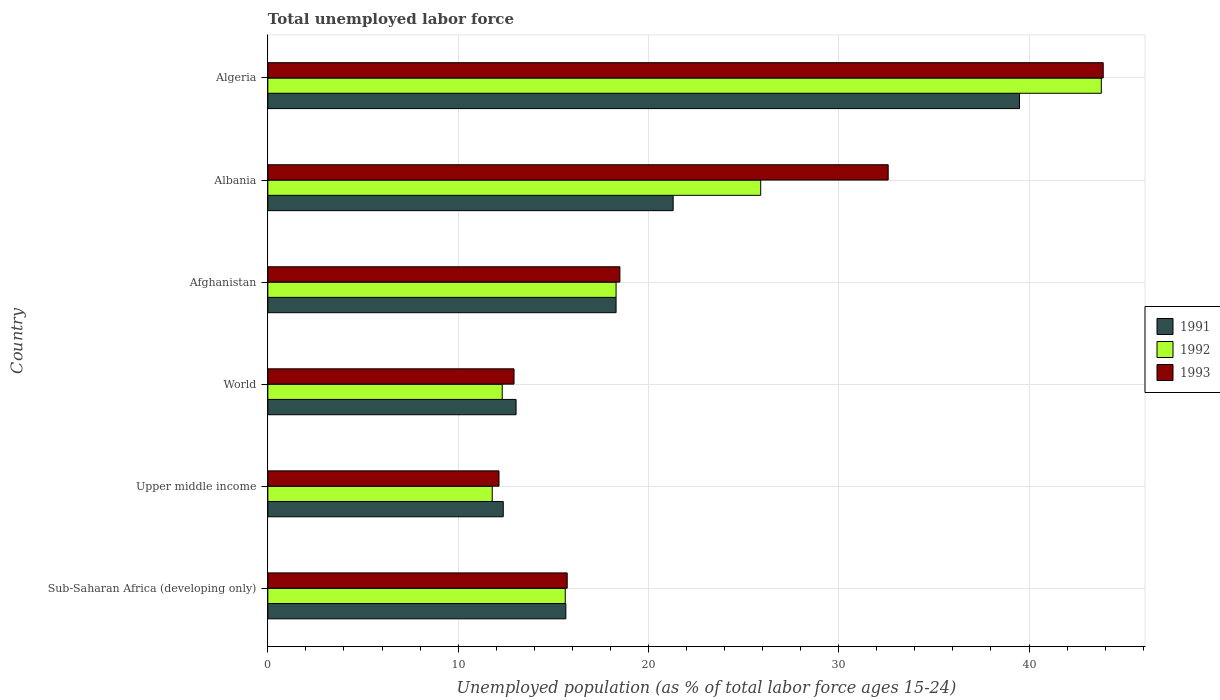How many groups of bars are there?
Keep it short and to the point. 6. Are the number of bars per tick equal to the number of legend labels?
Make the answer very short. Yes. What is the label of the 4th group of bars from the top?
Ensure brevity in your answer.  World. In how many cases, is the number of bars for a given country not equal to the number of legend labels?
Keep it short and to the point. 0. Across all countries, what is the maximum percentage of unemployed population in in 1991?
Give a very brief answer. 39.5. Across all countries, what is the minimum percentage of unemployed population in in 1991?
Give a very brief answer. 12.37. In which country was the percentage of unemployed population in in 1992 maximum?
Ensure brevity in your answer.  Algeria. In which country was the percentage of unemployed population in in 1991 minimum?
Offer a terse response. Upper middle income. What is the total percentage of unemployed population in in 1992 in the graph?
Provide a succinct answer. 127.74. What is the difference between the percentage of unemployed population in in 1993 in Algeria and that in Upper middle income?
Provide a succinct answer. 31.75. What is the difference between the percentage of unemployed population in in 1993 in Albania and the percentage of unemployed population in in 1991 in Sub-Saharan Africa (developing only)?
Keep it short and to the point. 16.94. What is the average percentage of unemployed population in in 1992 per country?
Your answer should be very brief. 21.29. What is the difference between the percentage of unemployed population in in 1993 and percentage of unemployed population in in 1992 in World?
Give a very brief answer. 0.62. What is the ratio of the percentage of unemployed population in in 1991 in Algeria to that in Upper middle income?
Make the answer very short. 3.19. Is the percentage of unemployed population in in 1991 in Albania less than that in Sub-Saharan Africa (developing only)?
Give a very brief answer. No. What is the difference between the highest and the second highest percentage of unemployed population in in 1991?
Make the answer very short. 18.2. What is the difference between the highest and the lowest percentage of unemployed population in in 1992?
Keep it short and to the point. 32.01. In how many countries, is the percentage of unemployed population in in 1991 greater than the average percentage of unemployed population in in 1991 taken over all countries?
Keep it short and to the point. 2. What does the 1st bar from the top in World represents?
Keep it short and to the point. 1993. What does the 2nd bar from the bottom in World represents?
Offer a terse response. 1992. How many bars are there?
Make the answer very short. 18. What is the difference between two consecutive major ticks on the X-axis?
Provide a short and direct response. 10. Does the graph contain grids?
Give a very brief answer. Yes. Where does the legend appear in the graph?
Offer a terse response. Center right. What is the title of the graph?
Offer a very short reply. Total unemployed labor force. What is the label or title of the X-axis?
Make the answer very short. Unemployed population (as % of total labor force ages 15-24). What is the Unemployed population (as % of total labor force ages 15-24) of 1991 in Sub-Saharan Africa (developing only)?
Keep it short and to the point. 15.66. What is the Unemployed population (as % of total labor force ages 15-24) of 1992 in Sub-Saharan Africa (developing only)?
Ensure brevity in your answer.  15.63. What is the Unemployed population (as % of total labor force ages 15-24) in 1993 in Sub-Saharan Africa (developing only)?
Provide a succinct answer. 15.73. What is the Unemployed population (as % of total labor force ages 15-24) in 1991 in Upper middle income?
Offer a very short reply. 12.37. What is the Unemployed population (as % of total labor force ages 15-24) of 1992 in Upper middle income?
Give a very brief answer. 11.79. What is the Unemployed population (as % of total labor force ages 15-24) of 1993 in Upper middle income?
Ensure brevity in your answer.  12.15. What is the Unemployed population (as % of total labor force ages 15-24) in 1991 in World?
Provide a short and direct response. 13.04. What is the Unemployed population (as % of total labor force ages 15-24) of 1992 in World?
Provide a succinct answer. 12.32. What is the Unemployed population (as % of total labor force ages 15-24) of 1993 in World?
Make the answer very short. 12.94. What is the Unemployed population (as % of total labor force ages 15-24) in 1991 in Afghanistan?
Make the answer very short. 18.3. What is the Unemployed population (as % of total labor force ages 15-24) in 1992 in Afghanistan?
Keep it short and to the point. 18.3. What is the Unemployed population (as % of total labor force ages 15-24) in 1991 in Albania?
Provide a succinct answer. 21.3. What is the Unemployed population (as % of total labor force ages 15-24) of 1992 in Albania?
Make the answer very short. 25.9. What is the Unemployed population (as % of total labor force ages 15-24) of 1993 in Albania?
Provide a short and direct response. 32.6. What is the Unemployed population (as % of total labor force ages 15-24) in 1991 in Algeria?
Your answer should be compact. 39.5. What is the Unemployed population (as % of total labor force ages 15-24) in 1992 in Algeria?
Your answer should be very brief. 43.8. What is the Unemployed population (as % of total labor force ages 15-24) in 1993 in Algeria?
Offer a very short reply. 43.9. Across all countries, what is the maximum Unemployed population (as % of total labor force ages 15-24) of 1991?
Provide a short and direct response. 39.5. Across all countries, what is the maximum Unemployed population (as % of total labor force ages 15-24) of 1992?
Provide a succinct answer. 43.8. Across all countries, what is the maximum Unemployed population (as % of total labor force ages 15-24) of 1993?
Give a very brief answer. 43.9. Across all countries, what is the minimum Unemployed population (as % of total labor force ages 15-24) in 1991?
Give a very brief answer. 12.37. Across all countries, what is the minimum Unemployed population (as % of total labor force ages 15-24) of 1992?
Provide a succinct answer. 11.79. Across all countries, what is the minimum Unemployed population (as % of total labor force ages 15-24) of 1993?
Your response must be concise. 12.15. What is the total Unemployed population (as % of total labor force ages 15-24) of 1991 in the graph?
Offer a terse response. 120.18. What is the total Unemployed population (as % of total labor force ages 15-24) in 1992 in the graph?
Provide a succinct answer. 127.74. What is the total Unemployed population (as % of total labor force ages 15-24) in 1993 in the graph?
Your answer should be compact. 135.82. What is the difference between the Unemployed population (as % of total labor force ages 15-24) in 1991 in Sub-Saharan Africa (developing only) and that in Upper middle income?
Give a very brief answer. 3.29. What is the difference between the Unemployed population (as % of total labor force ages 15-24) of 1992 in Sub-Saharan Africa (developing only) and that in Upper middle income?
Give a very brief answer. 3.84. What is the difference between the Unemployed population (as % of total labor force ages 15-24) in 1993 in Sub-Saharan Africa (developing only) and that in Upper middle income?
Your answer should be compact. 3.58. What is the difference between the Unemployed population (as % of total labor force ages 15-24) in 1991 in Sub-Saharan Africa (developing only) and that in World?
Your answer should be compact. 2.62. What is the difference between the Unemployed population (as % of total labor force ages 15-24) of 1992 in Sub-Saharan Africa (developing only) and that in World?
Your answer should be very brief. 3.31. What is the difference between the Unemployed population (as % of total labor force ages 15-24) of 1993 in Sub-Saharan Africa (developing only) and that in World?
Your answer should be very brief. 2.79. What is the difference between the Unemployed population (as % of total labor force ages 15-24) of 1991 in Sub-Saharan Africa (developing only) and that in Afghanistan?
Offer a very short reply. -2.64. What is the difference between the Unemployed population (as % of total labor force ages 15-24) of 1992 in Sub-Saharan Africa (developing only) and that in Afghanistan?
Make the answer very short. -2.67. What is the difference between the Unemployed population (as % of total labor force ages 15-24) in 1993 in Sub-Saharan Africa (developing only) and that in Afghanistan?
Your answer should be very brief. -2.77. What is the difference between the Unemployed population (as % of total labor force ages 15-24) in 1991 in Sub-Saharan Africa (developing only) and that in Albania?
Your response must be concise. -5.64. What is the difference between the Unemployed population (as % of total labor force ages 15-24) of 1992 in Sub-Saharan Africa (developing only) and that in Albania?
Provide a succinct answer. -10.27. What is the difference between the Unemployed population (as % of total labor force ages 15-24) of 1993 in Sub-Saharan Africa (developing only) and that in Albania?
Provide a succinct answer. -16.87. What is the difference between the Unemployed population (as % of total labor force ages 15-24) in 1991 in Sub-Saharan Africa (developing only) and that in Algeria?
Provide a succinct answer. -23.84. What is the difference between the Unemployed population (as % of total labor force ages 15-24) of 1992 in Sub-Saharan Africa (developing only) and that in Algeria?
Offer a very short reply. -28.17. What is the difference between the Unemployed population (as % of total labor force ages 15-24) in 1993 in Sub-Saharan Africa (developing only) and that in Algeria?
Your response must be concise. -28.17. What is the difference between the Unemployed population (as % of total labor force ages 15-24) in 1991 in Upper middle income and that in World?
Keep it short and to the point. -0.67. What is the difference between the Unemployed population (as % of total labor force ages 15-24) of 1992 in Upper middle income and that in World?
Give a very brief answer. -0.52. What is the difference between the Unemployed population (as % of total labor force ages 15-24) in 1993 in Upper middle income and that in World?
Your answer should be compact. -0.79. What is the difference between the Unemployed population (as % of total labor force ages 15-24) in 1991 in Upper middle income and that in Afghanistan?
Provide a short and direct response. -5.93. What is the difference between the Unemployed population (as % of total labor force ages 15-24) in 1992 in Upper middle income and that in Afghanistan?
Give a very brief answer. -6.51. What is the difference between the Unemployed population (as % of total labor force ages 15-24) of 1993 in Upper middle income and that in Afghanistan?
Ensure brevity in your answer.  -6.35. What is the difference between the Unemployed population (as % of total labor force ages 15-24) of 1991 in Upper middle income and that in Albania?
Offer a very short reply. -8.93. What is the difference between the Unemployed population (as % of total labor force ages 15-24) of 1992 in Upper middle income and that in Albania?
Offer a very short reply. -14.11. What is the difference between the Unemployed population (as % of total labor force ages 15-24) of 1993 in Upper middle income and that in Albania?
Ensure brevity in your answer.  -20.45. What is the difference between the Unemployed population (as % of total labor force ages 15-24) in 1991 in Upper middle income and that in Algeria?
Your response must be concise. -27.13. What is the difference between the Unemployed population (as % of total labor force ages 15-24) of 1992 in Upper middle income and that in Algeria?
Provide a succinct answer. -32.01. What is the difference between the Unemployed population (as % of total labor force ages 15-24) of 1993 in Upper middle income and that in Algeria?
Your response must be concise. -31.75. What is the difference between the Unemployed population (as % of total labor force ages 15-24) in 1991 in World and that in Afghanistan?
Offer a terse response. -5.26. What is the difference between the Unemployed population (as % of total labor force ages 15-24) in 1992 in World and that in Afghanistan?
Provide a succinct answer. -5.98. What is the difference between the Unemployed population (as % of total labor force ages 15-24) in 1993 in World and that in Afghanistan?
Your answer should be compact. -5.56. What is the difference between the Unemployed population (as % of total labor force ages 15-24) of 1991 in World and that in Albania?
Your answer should be compact. -8.26. What is the difference between the Unemployed population (as % of total labor force ages 15-24) in 1992 in World and that in Albania?
Offer a terse response. -13.58. What is the difference between the Unemployed population (as % of total labor force ages 15-24) of 1993 in World and that in Albania?
Make the answer very short. -19.66. What is the difference between the Unemployed population (as % of total labor force ages 15-24) of 1991 in World and that in Algeria?
Keep it short and to the point. -26.46. What is the difference between the Unemployed population (as % of total labor force ages 15-24) in 1992 in World and that in Algeria?
Your answer should be very brief. -31.48. What is the difference between the Unemployed population (as % of total labor force ages 15-24) of 1993 in World and that in Algeria?
Your answer should be very brief. -30.96. What is the difference between the Unemployed population (as % of total labor force ages 15-24) of 1991 in Afghanistan and that in Albania?
Ensure brevity in your answer.  -3. What is the difference between the Unemployed population (as % of total labor force ages 15-24) in 1993 in Afghanistan and that in Albania?
Offer a very short reply. -14.1. What is the difference between the Unemployed population (as % of total labor force ages 15-24) of 1991 in Afghanistan and that in Algeria?
Your response must be concise. -21.2. What is the difference between the Unemployed population (as % of total labor force ages 15-24) of 1992 in Afghanistan and that in Algeria?
Your answer should be compact. -25.5. What is the difference between the Unemployed population (as % of total labor force ages 15-24) in 1993 in Afghanistan and that in Algeria?
Offer a very short reply. -25.4. What is the difference between the Unemployed population (as % of total labor force ages 15-24) of 1991 in Albania and that in Algeria?
Provide a succinct answer. -18.2. What is the difference between the Unemployed population (as % of total labor force ages 15-24) in 1992 in Albania and that in Algeria?
Keep it short and to the point. -17.9. What is the difference between the Unemployed population (as % of total labor force ages 15-24) in 1991 in Sub-Saharan Africa (developing only) and the Unemployed population (as % of total labor force ages 15-24) in 1992 in Upper middle income?
Your answer should be very brief. 3.87. What is the difference between the Unemployed population (as % of total labor force ages 15-24) of 1991 in Sub-Saharan Africa (developing only) and the Unemployed population (as % of total labor force ages 15-24) of 1993 in Upper middle income?
Your answer should be very brief. 3.51. What is the difference between the Unemployed population (as % of total labor force ages 15-24) of 1992 in Sub-Saharan Africa (developing only) and the Unemployed population (as % of total labor force ages 15-24) of 1993 in Upper middle income?
Provide a succinct answer. 3.48. What is the difference between the Unemployed population (as % of total labor force ages 15-24) of 1991 in Sub-Saharan Africa (developing only) and the Unemployed population (as % of total labor force ages 15-24) of 1992 in World?
Ensure brevity in your answer.  3.34. What is the difference between the Unemployed population (as % of total labor force ages 15-24) in 1991 in Sub-Saharan Africa (developing only) and the Unemployed population (as % of total labor force ages 15-24) in 1993 in World?
Offer a very short reply. 2.72. What is the difference between the Unemployed population (as % of total labor force ages 15-24) of 1992 in Sub-Saharan Africa (developing only) and the Unemployed population (as % of total labor force ages 15-24) of 1993 in World?
Provide a short and direct response. 2.69. What is the difference between the Unemployed population (as % of total labor force ages 15-24) in 1991 in Sub-Saharan Africa (developing only) and the Unemployed population (as % of total labor force ages 15-24) in 1992 in Afghanistan?
Provide a short and direct response. -2.64. What is the difference between the Unemployed population (as % of total labor force ages 15-24) of 1991 in Sub-Saharan Africa (developing only) and the Unemployed population (as % of total labor force ages 15-24) of 1993 in Afghanistan?
Ensure brevity in your answer.  -2.84. What is the difference between the Unemployed population (as % of total labor force ages 15-24) in 1992 in Sub-Saharan Africa (developing only) and the Unemployed population (as % of total labor force ages 15-24) in 1993 in Afghanistan?
Your response must be concise. -2.87. What is the difference between the Unemployed population (as % of total labor force ages 15-24) of 1991 in Sub-Saharan Africa (developing only) and the Unemployed population (as % of total labor force ages 15-24) of 1992 in Albania?
Your response must be concise. -10.24. What is the difference between the Unemployed population (as % of total labor force ages 15-24) in 1991 in Sub-Saharan Africa (developing only) and the Unemployed population (as % of total labor force ages 15-24) in 1993 in Albania?
Your response must be concise. -16.94. What is the difference between the Unemployed population (as % of total labor force ages 15-24) in 1992 in Sub-Saharan Africa (developing only) and the Unemployed population (as % of total labor force ages 15-24) in 1993 in Albania?
Your answer should be compact. -16.97. What is the difference between the Unemployed population (as % of total labor force ages 15-24) in 1991 in Sub-Saharan Africa (developing only) and the Unemployed population (as % of total labor force ages 15-24) in 1992 in Algeria?
Provide a succinct answer. -28.14. What is the difference between the Unemployed population (as % of total labor force ages 15-24) in 1991 in Sub-Saharan Africa (developing only) and the Unemployed population (as % of total labor force ages 15-24) in 1993 in Algeria?
Your answer should be very brief. -28.24. What is the difference between the Unemployed population (as % of total labor force ages 15-24) of 1992 in Sub-Saharan Africa (developing only) and the Unemployed population (as % of total labor force ages 15-24) of 1993 in Algeria?
Offer a very short reply. -28.27. What is the difference between the Unemployed population (as % of total labor force ages 15-24) in 1991 in Upper middle income and the Unemployed population (as % of total labor force ages 15-24) in 1992 in World?
Your answer should be very brief. 0.06. What is the difference between the Unemployed population (as % of total labor force ages 15-24) in 1991 in Upper middle income and the Unemployed population (as % of total labor force ages 15-24) in 1993 in World?
Give a very brief answer. -0.57. What is the difference between the Unemployed population (as % of total labor force ages 15-24) in 1992 in Upper middle income and the Unemployed population (as % of total labor force ages 15-24) in 1993 in World?
Ensure brevity in your answer.  -1.15. What is the difference between the Unemployed population (as % of total labor force ages 15-24) in 1991 in Upper middle income and the Unemployed population (as % of total labor force ages 15-24) in 1992 in Afghanistan?
Provide a short and direct response. -5.93. What is the difference between the Unemployed population (as % of total labor force ages 15-24) of 1991 in Upper middle income and the Unemployed population (as % of total labor force ages 15-24) of 1993 in Afghanistan?
Provide a short and direct response. -6.13. What is the difference between the Unemployed population (as % of total labor force ages 15-24) of 1992 in Upper middle income and the Unemployed population (as % of total labor force ages 15-24) of 1993 in Afghanistan?
Keep it short and to the point. -6.71. What is the difference between the Unemployed population (as % of total labor force ages 15-24) in 1991 in Upper middle income and the Unemployed population (as % of total labor force ages 15-24) in 1992 in Albania?
Give a very brief answer. -13.53. What is the difference between the Unemployed population (as % of total labor force ages 15-24) of 1991 in Upper middle income and the Unemployed population (as % of total labor force ages 15-24) of 1993 in Albania?
Make the answer very short. -20.23. What is the difference between the Unemployed population (as % of total labor force ages 15-24) of 1992 in Upper middle income and the Unemployed population (as % of total labor force ages 15-24) of 1993 in Albania?
Give a very brief answer. -20.81. What is the difference between the Unemployed population (as % of total labor force ages 15-24) of 1991 in Upper middle income and the Unemployed population (as % of total labor force ages 15-24) of 1992 in Algeria?
Your answer should be compact. -31.43. What is the difference between the Unemployed population (as % of total labor force ages 15-24) of 1991 in Upper middle income and the Unemployed population (as % of total labor force ages 15-24) of 1993 in Algeria?
Your answer should be very brief. -31.53. What is the difference between the Unemployed population (as % of total labor force ages 15-24) of 1992 in Upper middle income and the Unemployed population (as % of total labor force ages 15-24) of 1993 in Algeria?
Keep it short and to the point. -32.11. What is the difference between the Unemployed population (as % of total labor force ages 15-24) in 1991 in World and the Unemployed population (as % of total labor force ages 15-24) in 1992 in Afghanistan?
Your answer should be very brief. -5.26. What is the difference between the Unemployed population (as % of total labor force ages 15-24) of 1991 in World and the Unemployed population (as % of total labor force ages 15-24) of 1993 in Afghanistan?
Keep it short and to the point. -5.46. What is the difference between the Unemployed population (as % of total labor force ages 15-24) in 1992 in World and the Unemployed population (as % of total labor force ages 15-24) in 1993 in Afghanistan?
Provide a short and direct response. -6.18. What is the difference between the Unemployed population (as % of total labor force ages 15-24) in 1991 in World and the Unemployed population (as % of total labor force ages 15-24) in 1992 in Albania?
Give a very brief answer. -12.86. What is the difference between the Unemployed population (as % of total labor force ages 15-24) of 1991 in World and the Unemployed population (as % of total labor force ages 15-24) of 1993 in Albania?
Offer a very short reply. -19.56. What is the difference between the Unemployed population (as % of total labor force ages 15-24) of 1992 in World and the Unemployed population (as % of total labor force ages 15-24) of 1993 in Albania?
Give a very brief answer. -20.28. What is the difference between the Unemployed population (as % of total labor force ages 15-24) of 1991 in World and the Unemployed population (as % of total labor force ages 15-24) of 1992 in Algeria?
Give a very brief answer. -30.76. What is the difference between the Unemployed population (as % of total labor force ages 15-24) of 1991 in World and the Unemployed population (as % of total labor force ages 15-24) of 1993 in Algeria?
Ensure brevity in your answer.  -30.86. What is the difference between the Unemployed population (as % of total labor force ages 15-24) in 1992 in World and the Unemployed population (as % of total labor force ages 15-24) in 1993 in Algeria?
Your response must be concise. -31.58. What is the difference between the Unemployed population (as % of total labor force ages 15-24) in 1991 in Afghanistan and the Unemployed population (as % of total labor force ages 15-24) in 1993 in Albania?
Offer a very short reply. -14.3. What is the difference between the Unemployed population (as % of total labor force ages 15-24) of 1992 in Afghanistan and the Unemployed population (as % of total labor force ages 15-24) of 1993 in Albania?
Your answer should be very brief. -14.3. What is the difference between the Unemployed population (as % of total labor force ages 15-24) in 1991 in Afghanistan and the Unemployed population (as % of total labor force ages 15-24) in 1992 in Algeria?
Ensure brevity in your answer.  -25.5. What is the difference between the Unemployed population (as % of total labor force ages 15-24) of 1991 in Afghanistan and the Unemployed population (as % of total labor force ages 15-24) of 1993 in Algeria?
Provide a succinct answer. -25.6. What is the difference between the Unemployed population (as % of total labor force ages 15-24) of 1992 in Afghanistan and the Unemployed population (as % of total labor force ages 15-24) of 1993 in Algeria?
Your answer should be compact. -25.6. What is the difference between the Unemployed population (as % of total labor force ages 15-24) of 1991 in Albania and the Unemployed population (as % of total labor force ages 15-24) of 1992 in Algeria?
Your answer should be very brief. -22.5. What is the difference between the Unemployed population (as % of total labor force ages 15-24) in 1991 in Albania and the Unemployed population (as % of total labor force ages 15-24) in 1993 in Algeria?
Provide a succinct answer. -22.6. What is the average Unemployed population (as % of total labor force ages 15-24) in 1991 per country?
Offer a terse response. 20.03. What is the average Unemployed population (as % of total labor force ages 15-24) of 1992 per country?
Keep it short and to the point. 21.29. What is the average Unemployed population (as % of total labor force ages 15-24) in 1993 per country?
Your answer should be compact. 22.64. What is the difference between the Unemployed population (as % of total labor force ages 15-24) in 1991 and Unemployed population (as % of total labor force ages 15-24) in 1992 in Sub-Saharan Africa (developing only)?
Keep it short and to the point. 0.03. What is the difference between the Unemployed population (as % of total labor force ages 15-24) of 1991 and Unemployed population (as % of total labor force ages 15-24) of 1993 in Sub-Saharan Africa (developing only)?
Provide a succinct answer. -0.07. What is the difference between the Unemployed population (as % of total labor force ages 15-24) in 1992 and Unemployed population (as % of total labor force ages 15-24) in 1993 in Sub-Saharan Africa (developing only)?
Offer a very short reply. -0.1. What is the difference between the Unemployed population (as % of total labor force ages 15-24) of 1991 and Unemployed population (as % of total labor force ages 15-24) of 1992 in Upper middle income?
Ensure brevity in your answer.  0.58. What is the difference between the Unemployed population (as % of total labor force ages 15-24) in 1991 and Unemployed population (as % of total labor force ages 15-24) in 1993 in Upper middle income?
Provide a short and direct response. 0.22. What is the difference between the Unemployed population (as % of total labor force ages 15-24) in 1992 and Unemployed population (as % of total labor force ages 15-24) in 1993 in Upper middle income?
Make the answer very short. -0.36. What is the difference between the Unemployed population (as % of total labor force ages 15-24) in 1991 and Unemployed population (as % of total labor force ages 15-24) in 1992 in World?
Offer a terse response. 0.73. What is the difference between the Unemployed population (as % of total labor force ages 15-24) in 1991 and Unemployed population (as % of total labor force ages 15-24) in 1993 in World?
Make the answer very short. 0.11. What is the difference between the Unemployed population (as % of total labor force ages 15-24) of 1992 and Unemployed population (as % of total labor force ages 15-24) of 1993 in World?
Provide a short and direct response. -0.62. What is the difference between the Unemployed population (as % of total labor force ages 15-24) in 1991 and Unemployed population (as % of total labor force ages 15-24) in 1992 in Afghanistan?
Your answer should be compact. 0. What is the difference between the Unemployed population (as % of total labor force ages 15-24) of 1991 and Unemployed population (as % of total labor force ages 15-24) of 1993 in Afghanistan?
Your response must be concise. -0.2. What is the difference between the Unemployed population (as % of total labor force ages 15-24) of 1992 and Unemployed population (as % of total labor force ages 15-24) of 1993 in Afghanistan?
Offer a terse response. -0.2. What is the difference between the Unemployed population (as % of total labor force ages 15-24) of 1991 and Unemployed population (as % of total labor force ages 15-24) of 1992 in Albania?
Offer a terse response. -4.6. What is the difference between the Unemployed population (as % of total labor force ages 15-24) of 1991 and Unemployed population (as % of total labor force ages 15-24) of 1993 in Albania?
Offer a very short reply. -11.3. What is the difference between the Unemployed population (as % of total labor force ages 15-24) of 1991 and Unemployed population (as % of total labor force ages 15-24) of 1992 in Algeria?
Ensure brevity in your answer.  -4.3. What is the difference between the Unemployed population (as % of total labor force ages 15-24) in 1991 and Unemployed population (as % of total labor force ages 15-24) in 1993 in Algeria?
Make the answer very short. -4.4. What is the ratio of the Unemployed population (as % of total labor force ages 15-24) in 1991 in Sub-Saharan Africa (developing only) to that in Upper middle income?
Provide a short and direct response. 1.27. What is the ratio of the Unemployed population (as % of total labor force ages 15-24) in 1992 in Sub-Saharan Africa (developing only) to that in Upper middle income?
Your answer should be very brief. 1.33. What is the ratio of the Unemployed population (as % of total labor force ages 15-24) in 1993 in Sub-Saharan Africa (developing only) to that in Upper middle income?
Your answer should be very brief. 1.29. What is the ratio of the Unemployed population (as % of total labor force ages 15-24) in 1991 in Sub-Saharan Africa (developing only) to that in World?
Keep it short and to the point. 1.2. What is the ratio of the Unemployed population (as % of total labor force ages 15-24) of 1992 in Sub-Saharan Africa (developing only) to that in World?
Ensure brevity in your answer.  1.27. What is the ratio of the Unemployed population (as % of total labor force ages 15-24) of 1993 in Sub-Saharan Africa (developing only) to that in World?
Keep it short and to the point. 1.22. What is the ratio of the Unemployed population (as % of total labor force ages 15-24) of 1991 in Sub-Saharan Africa (developing only) to that in Afghanistan?
Keep it short and to the point. 0.86. What is the ratio of the Unemployed population (as % of total labor force ages 15-24) in 1992 in Sub-Saharan Africa (developing only) to that in Afghanistan?
Your answer should be very brief. 0.85. What is the ratio of the Unemployed population (as % of total labor force ages 15-24) in 1993 in Sub-Saharan Africa (developing only) to that in Afghanistan?
Make the answer very short. 0.85. What is the ratio of the Unemployed population (as % of total labor force ages 15-24) in 1991 in Sub-Saharan Africa (developing only) to that in Albania?
Offer a terse response. 0.74. What is the ratio of the Unemployed population (as % of total labor force ages 15-24) of 1992 in Sub-Saharan Africa (developing only) to that in Albania?
Provide a succinct answer. 0.6. What is the ratio of the Unemployed population (as % of total labor force ages 15-24) of 1993 in Sub-Saharan Africa (developing only) to that in Albania?
Provide a succinct answer. 0.48. What is the ratio of the Unemployed population (as % of total labor force ages 15-24) of 1991 in Sub-Saharan Africa (developing only) to that in Algeria?
Your answer should be compact. 0.4. What is the ratio of the Unemployed population (as % of total labor force ages 15-24) in 1992 in Sub-Saharan Africa (developing only) to that in Algeria?
Give a very brief answer. 0.36. What is the ratio of the Unemployed population (as % of total labor force ages 15-24) in 1993 in Sub-Saharan Africa (developing only) to that in Algeria?
Ensure brevity in your answer.  0.36. What is the ratio of the Unemployed population (as % of total labor force ages 15-24) of 1991 in Upper middle income to that in World?
Your response must be concise. 0.95. What is the ratio of the Unemployed population (as % of total labor force ages 15-24) in 1992 in Upper middle income to that in World?
Provide a succinct answer. 0.96. What is the ratio of the Unemployed population (as % of total labor force ages 15-24) of 1993 in Upper middle income to that in World?
Provide a succinct answer. 0.94. What is the ratio of the Unemployed population (as % of total labor force ages 15-24) of 1991 in Upper middle income to that in Afghanistan?
Your response must be concise. 0.68. What is the ratio of the Unemployed population (as % of total labor force ages 15-24) in 1992 in Upper middle income to that in Afghanistan?
Ensure brevity in your answer.  0.64. What is the ratio of the Unemployed population (as % of total labor force ages 15-24) in 1993 in Upper middle income to that in Afghanistan?
Ensure brevity in your answer.  0.66. What is the ratio of the Unemployed population (as % of total labor force ages 15-24) of 1991 in Upper middle income to that in Albania?
Provide a succinct answer. 0.58. What is the ratio of the Unemployed population (as % of total labor force ages 15-24) in 1992 in Upper middle income to that in Albania?
Provide a succinct answer. 0.46. What is the ratio of the Unemployed population (as % of total labor force ages 15-24) in 1993 in Upper middle income to that in Albania?
Keep it short and to the point. 0.37. What is the ratio of the Unemployed population (as % of total labor force ages 15-24) in 1991 in Upper middle income to that in Algeria?
Offer a terse response. 0.31. What is the ratio of the Unemployed population (as % of total labor force ages 15-24) in 1992 in Upper middle income to that in Algeria?
Keep it short and to the point. 0.27. What is the ratio of the Unemployed population (as % of total labor force ages 15-24) in 1993 in Upper middle income to that in Algeria?
Your answer should be compact. 0.28. What is the ratio of the Unemployed population (as % of total labor force ages 15-24) of 1991 in World to that in Afghanistan?
Keep it short and to the point. 0.71. What is the ratio of the Unemployed population (as % of total labor force ages 15-24) in 1992 in World to that in Afghanistan?
Provide a short and direct response. 0.67. What is the ratio of the Unemployed population (as % of total labor force ages 15-24) of 1993 in World to that in Afghanistan?
Offer a very short reply. 0.7. What is the ratio of the Unemployed population (as % of total labor force ages 15-24) of 1991 in World to that in Albania?
Your response must be concise. 0.61. What is the ratio of the Unemployed population (as % of total labor force ages 15-24) of 1992 in World to that in Albania?
Keep it short and to the point. 0.48. What is the ratio of the Unemployed population (as % of total labor force ages 15-24) of 1993 in World to that in Albania?
Offer a very short reply. 0.4. What is the ratio of the Unemployed population (as % of total labor force ages 15-24) in 1991 in World to that in Algeria?
Offer a very short reply. 0.33. What is the ratio of the Unemployed population (as % of total labor force ages 15-24) in 1992 in World to that in Algeria?
Provide a short and direct response. 0.28. What is the ratio of the Unemployed population (as % of total labor force ages 15-24) of 1993 in World to that in Algeria?
Keep it short and to the point. 0.29. What is the ratio of the Unemployed population (as % of total labor force ages 15-24) of 1991 in Afghanistan to that in Albania?
Provide a succinct answer. 0.86. What is the ratio of the Unemployed population (as % of total labor force ages 15-24) in 1992 in Afghanistan to that in Albania?
Offer a very short reply. 0.71. What is the ratio of the Unemployed population (as % of total labor force ages 15-24) of 1993 in Afghanistan to that in Albania?
Provide a short and direct response. 0.57. What is the ratio of the Unemployed population (as % of total labor force ages 15-24) of 1991 in Afghanistan to that in Algeria?
Offer a very short reply. 0.46. What is the ratio of the Unemployed population (as % of total labor force ages 15-24) in 1992 in Afghanistan to that in Algeria?
Provide a short and direct response. 0.42. What is the ratio of the Unemployed population (as % of total labor force ages 15-24) of 1993 in Afghanistan to that in Algeria?
Offer a terse response. 0.42. What is the ratio of the Unemployed population (as % of total labor force ages 15-24) in 1991 in Albania to that in Algeria?
Your answer should be compact. 0.54. What is the ratio of the Unemployed population (as % of total labor force ages 15-24) of 1992 in Albania to that in Algeria?
Give a very brief answer. 0.59. What is the ratio of the Unemployed population (as % of total labor force ages 15-24) in 1993 in Albania to that in Algeria?
Your answer should be very brief. 0.74. What is the difference between the highest and the second highest Unemployed population (as % of total labor force ages 15-24) of 1992?
Your answer should be compact. 17.9. What is the difference between the highest and the lowest Unemployed population (as % of total labor force ages 15-24) in 1991?
Your response must be concise. 27.13. What is the difference between the highest and the lowest Unemployed population (as % of total labor force ages 15-24) in 1992?
Ensure brevity in your answer.  32.01. What is the difference between the highest and the lowest Unemployed population (as % of total labor force ages 15-24) in 1993?
Provide a succinct answer. 31.75. 